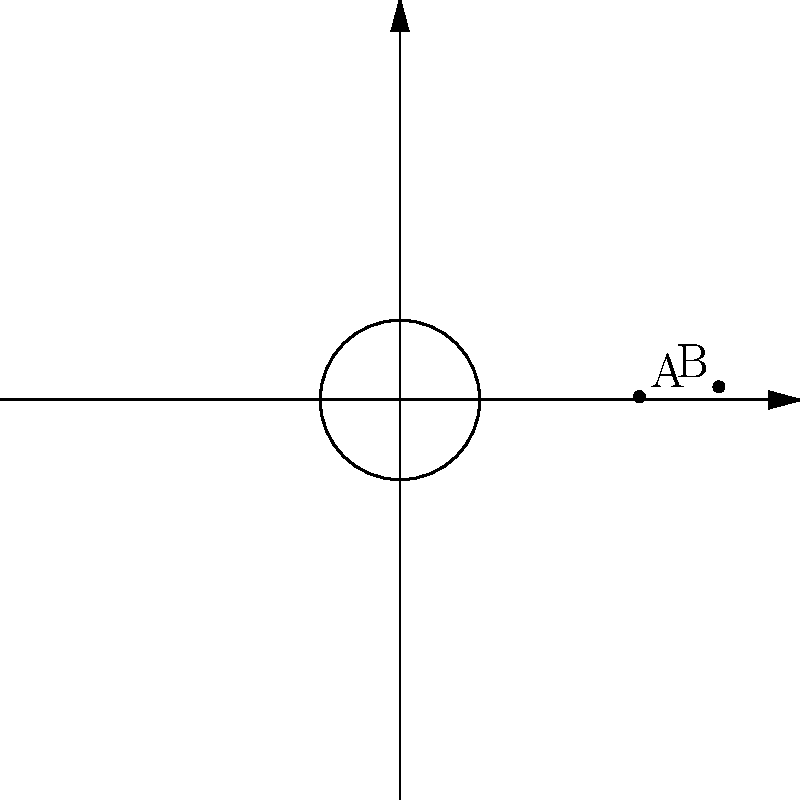As part of a community outreach program, Hackney Council is analyzing the distribution of its community centers. Two centers, A and B, are located at polar coordinates $(3, \frac{\pi}{4})$ and $(4, \frac{3\pi}{4})$ respectively, where distances are measured in kilometers. Calculate the straight-line distance between these two community centers. To find the distance between two points in polar coordinates, we can use the polar form of the distance formula:

$$d = \sqrt{r_1^2 + r_2^2 - 2r_1r_2 \cos(\theta_2 - \theta_1)}$$

Where:
$r_1 = 3$ km (distance of point A from origin)
$r_2 = 4$ km (distance of point B from origin)
$\theta_1 = \frac{\pi}{4}$ (angle of point A)
$\theta_2 = \frac{3\pi}{4}$ (angle of point B)

Steps:
1) First, calculate $\theta_2 - \theta_1$:
   $$\frac{3\pi}{4} - \frac{\pi}{4} = \frac{\pi}{2}$$

2) Calculate $\cos(\theta_2 - \theta_1)$:
   $$\cos(\frac{\pi}{2}) = 0$$

3) Now, substitute all values into the formula:
   $$d = \sqrt{3^2 + 4^2 - 2(3)(4)(0)}$$

4) Simplify:
   $$d = \sqrt{9 + 16 - 0} = \sqrt{25} = 5$$

Therefore, the distance between the two community centers is 5 kilometers.
Answer: 5 km 